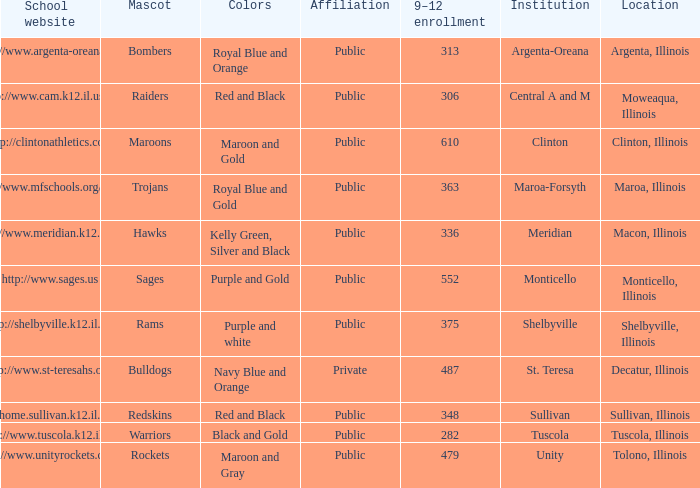What's the internet site for the academic facility in macon, illinois? Http://www.meridian.k12.il.us/. 